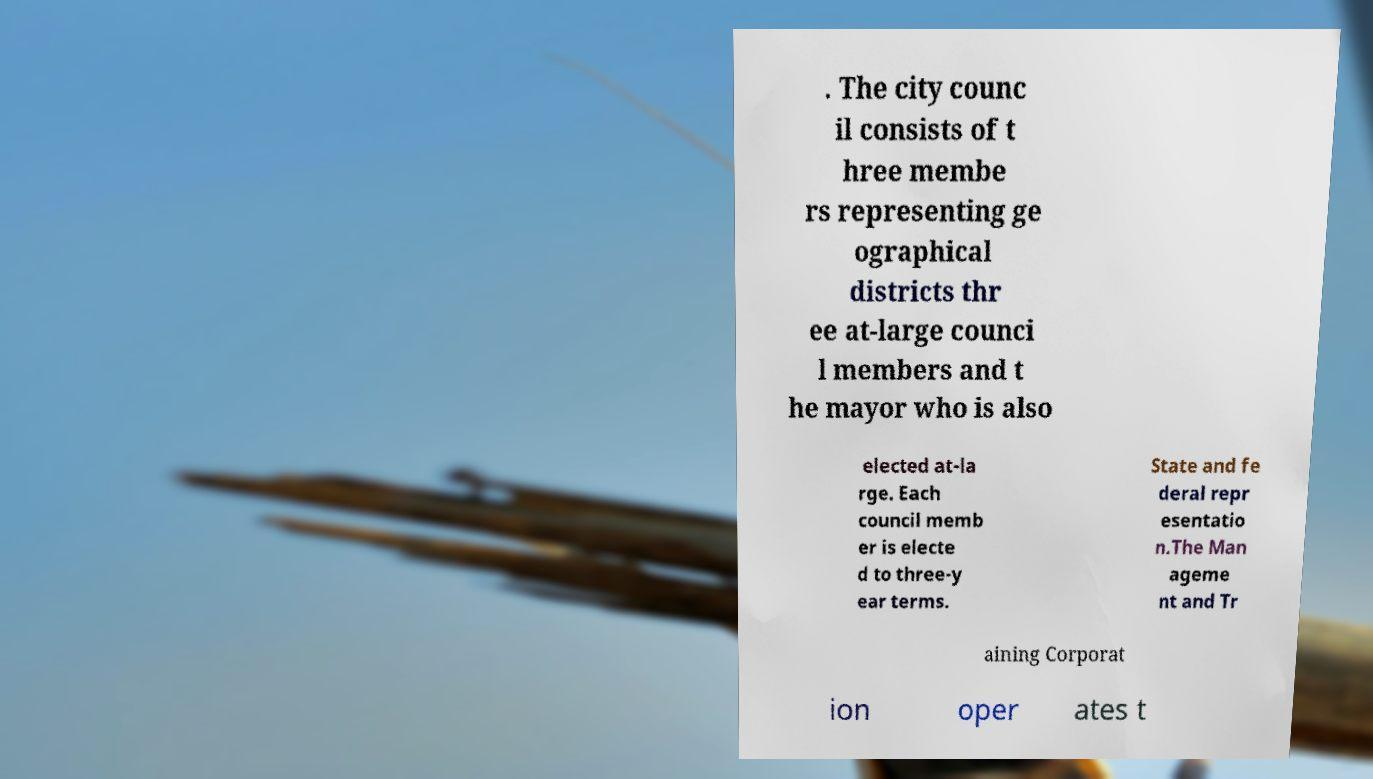Please identify and transcribe the text found in this image. . The city counc il consists of t hree membe rs representing ge ographical districts thr ee at-large counci l members and t he mayor who is also elected at-la rge. Each council memb er is electe d to three-y ear terms. State and fe deral repr esentatio n.The Man ageme nt and Tr aining Corporat ion oper ates t 